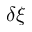Convert formula to latex. <formula><loc_0><loc_0><loc_500><loc_500>\delta \xi</formula> 